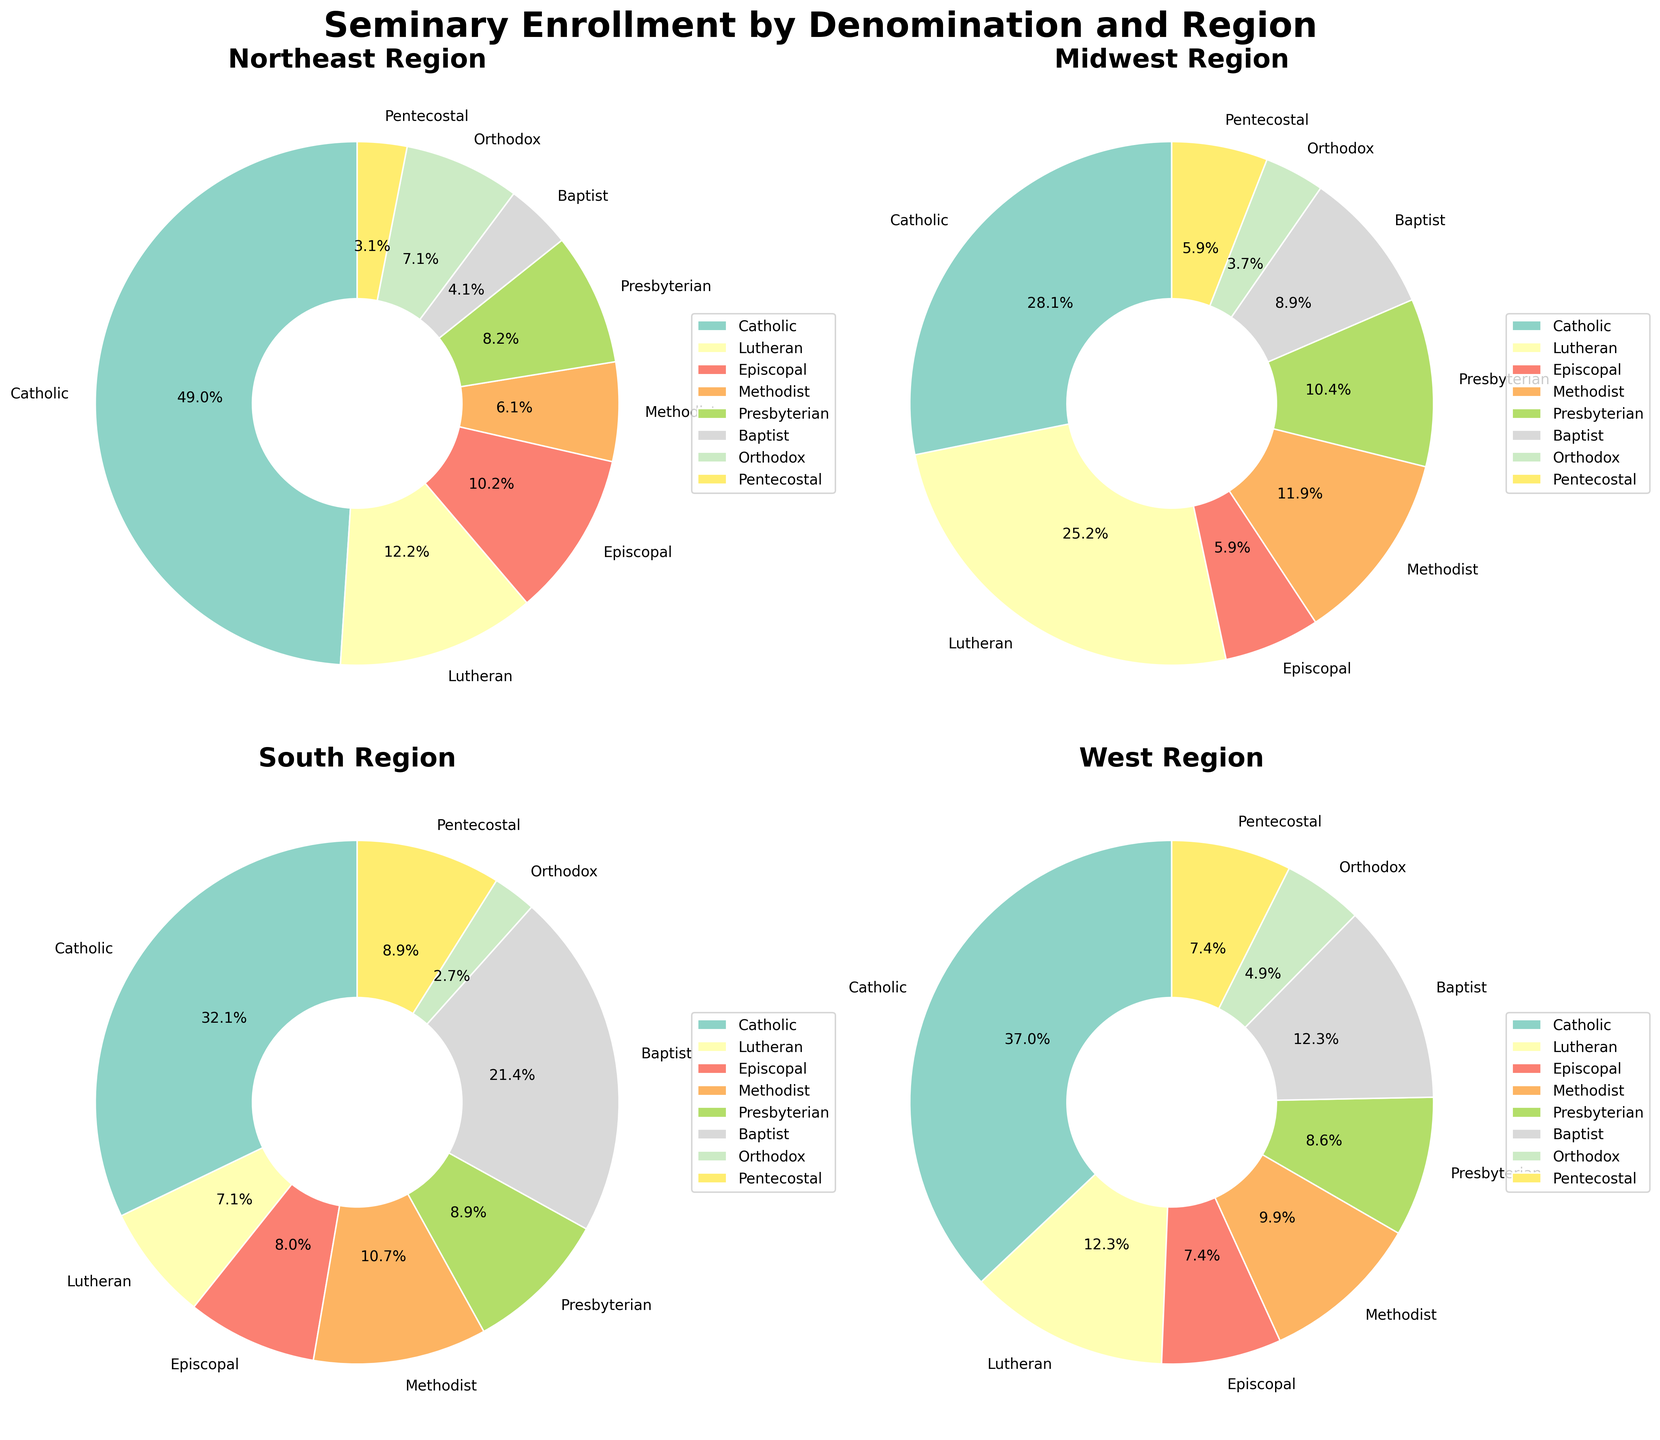What is the title of the figure? The title is typically found at the top of the figure and is used to describe the main topic or purpose of the figure.
Answer: Seminary Enrollment by Denomination and Region Which region has the highest enrollment for the Catholic denomination? To answer this, look at the pie chart segments labeled "Catholic" in each regional subplot and see which one has the highest value or percentage.
Answer: South What percentage of the Midwest region's enrollment is Lutheran? Check the section labeled "Lutheran" in the Midwest region's pie chart and read the percentage displayed next to it.
Answer: 34.4% How does the enrollment of the Episcopal denomination in the South compare to the West? Look at the pie chart sections labeled "Episcopal" in both the South and West regions, and compare their values or percentages.
Answer: The South has higher Episcopal enrollment than the West Summarize the predominant denomination in each region. For each region (Northeast, Midwest, South, West), identify the largest segment in the pie chart.
Answer: Northeast: Catholic, Midwest: Catholic, South: Catholic, West: Catholic What is the combined percentage of Methodist and Presbyterian enrollments in the Northeast region? Find the percentages of the Methodist and Presbyterian segments in the Northeast pie chart, and then add them together.
Answer: 13.6% How many denominations have a presence in all four regions? Count the denominations that have a segment in each of the four pie charts.
Answer: Eight Which region has the lowest total enrollment? Compare the total areas of the pie charts or the sum of values for all segments in each region to determine which one is smallest.
Answer: West Which denomination has the least enrollment in the Midwest? Identify the smallest segment in the Midwest region's pie chart and check which denomination it represents.
Answer: Orthodox By how much does Baptist enrollment in the South outweigh Northeast? Find the enrollment of the Baptist denomination in both the South and Northeast regions, then subtract the Northeast value from the South value.
Answer: 1100 